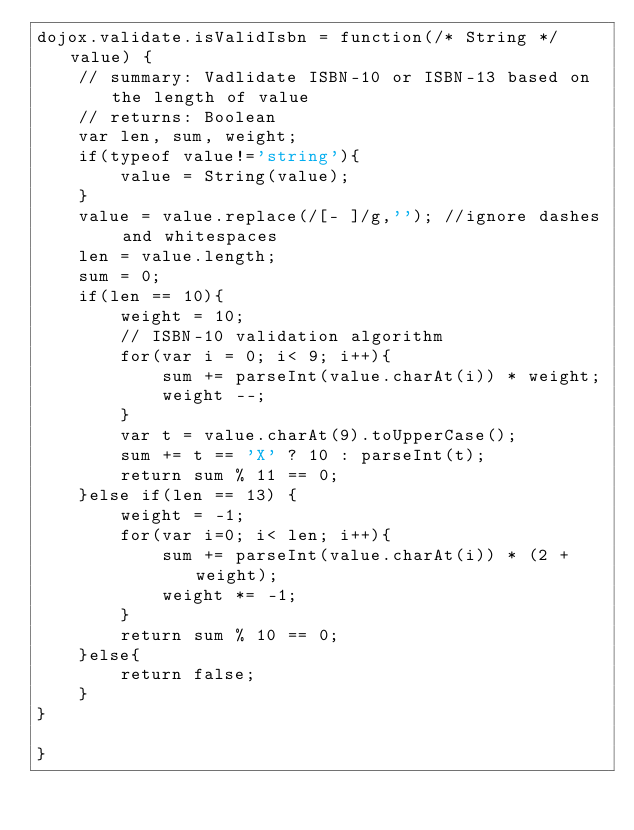<code> <loc_0><loc_0><loc_500><loc_500><_JavaScript_>dojox.validate.isValidIsbn = function(/* String */value) {
	// summary: Vadlidate ISBN-10 or ISBN-13 based on the length of value
	// returns: Boolean
	var len, sum, weight;
	if(typeof value!='string'){
		value = String(value);
	}
	value = value.replace(/[- ]/g,''); //ignore dashes and whitespaces
	len = value.length;
	sum = 0;
	if(len == 10){
		weight = 10;
		// ISBN-10 validation algorithm
		for(var i = 0; i< 9; i++){
			sum += parseInt(value.charAt(i)) * weight;
			weight --;
		}
		var t = value.charAt(9).toUpperCase();
		sum += t == 'X' ? 10 : parseInt(t);
		return sum % 11 == 0;
	}else if(len == 13) {
		weight = -1;
		for(var i=0; i< len; i++){
			sum += parseInt(value.charAt(i)) * (2 + weight);
			weight *= -1;
		}
		return sum % 10 == 0;
	}else{
		return false;
	}
}

}
</code> 